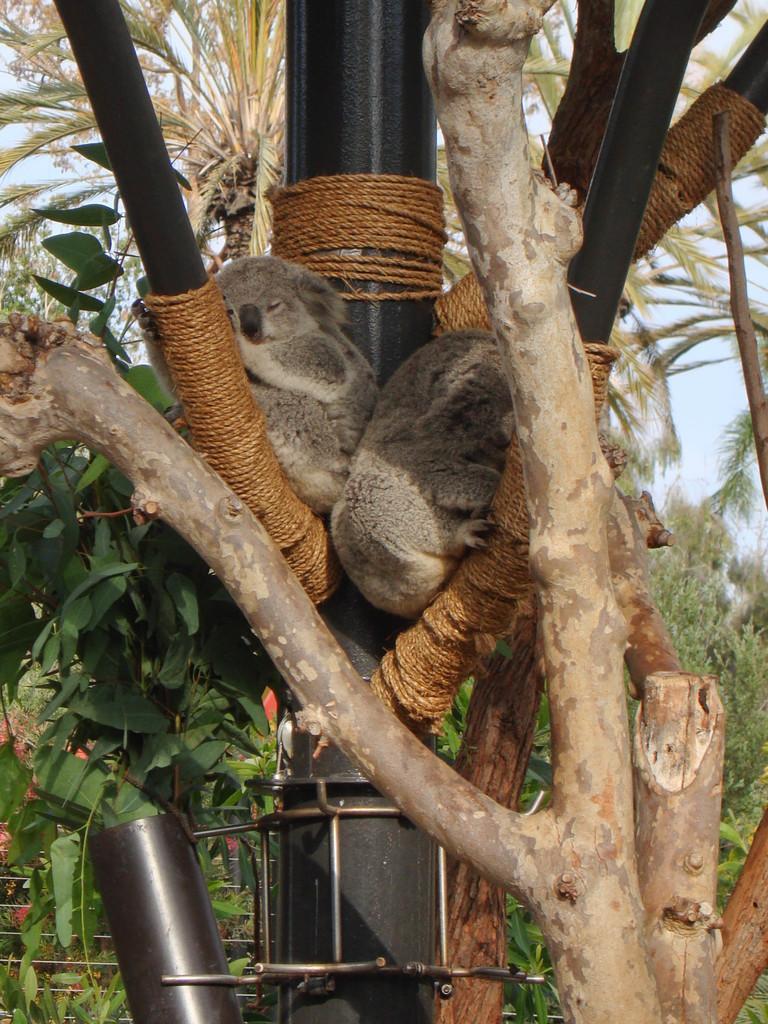In one or two sentences, can you explain what this image depicts? Here we see trees and a metal pole and we can see two bears seated on the pole 